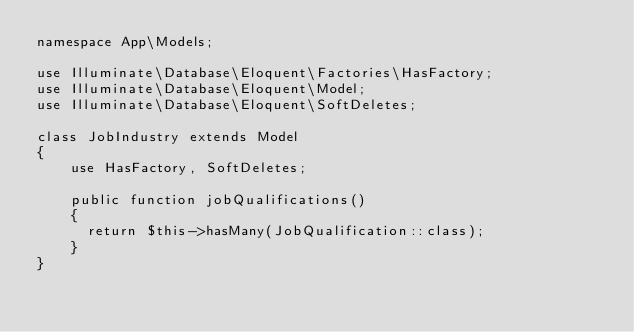Convert code to text. <code><loc_0><loc_0><loc_500><loc_500><_PHP_>namespace App\Models;

use Illuminate\Database\Eloquent\Factories\HasFactory;
use Illuminate\Database\Eloquent\Model;
use Illuminate\Database\Eloquent\SoftDeletes;

class JobIndustry extends Model
{
    use HasFactory, SoftDeletes;

    public function jobQualifications()
    {
    	return $this->hasMany(JobQualification::class);
    }
}
</code> 